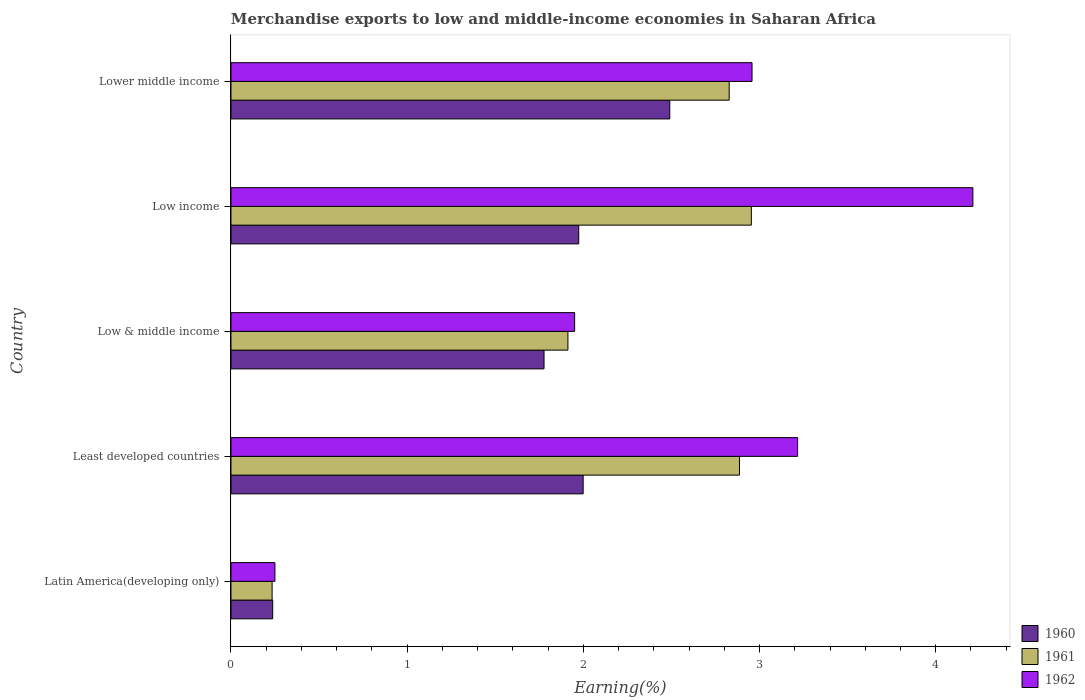Are the number of bars per tick equal to the number of legend labels?
Provide a short and direct response. Yes. Are the number of bars on each tick of the Y-axis equal?
Make the answer very short. Yes. How many bars are there on the 4th tick from the top?
Your response must be concise. 3. What is the label of the 4th group of bars from the top?
Give a very brief answer. Least developed countries. What is the percentage of amount earned from merchandise exports in 1960 in Low income?
Give a very brief answer. 1.97. Across all countries, what is the maximum percentage of amount earned from merchandise exports in 1960?
Provide a short and direct response. 2.49. Across all countries, what is the minimum percentage of amount earned from merchandise exports in 1962?
Offer a terse response. 0.25. In which country was the percentage of amount earned from merchandise exports in 1962 maximum?
Your answer should be very brief. Low income. In which country was the percentage of amount earned from merchandise exports in 1960 minimum?
Keep it short and to the point. Latin America(developing only). What is the total percentage of amount earned from merchandise exports in 1962 in the graph?
Provide a succinct answer. 12.58. What is the difference between the percentage of amount earned from merchandise exports in 1962 in Low & middle income and that in Low income?
Make the answer very short. -2.26. What is the difference between the percentage of amount earned from merchandise exports in 1962 in Latin America(developing only) and the percentage of amount earned from merchandise exports in 1961 in Low & middle income?
Provide a succinct answer. -1.66. What is the average percentage of amount earned from merchandise exports in 1962 per country?
Offer a very short reply. 2.52. What is the difference between the percentage of amount earned from merchandise exports in 1960 and percentage of amount earned from merchandise exports in 1962 in Low income?
Give a very brief answer. -2.24. What is the ratio of the percentage of amount earned from merchandise exports in 1961 in Latin America(developing only) to that in Lower middle income?
Offer a terse response. 0.08. Is the difference between the percentage of amount earned from merchandise exports in 1960 in Least developed countries and Low & middle income greater than the difference between the percentage of amount earned from merchandise exports in 1962 in Least developed countries and Low & middle income?
Give a very brief answer. No. What is the difference between the highest and the second highest percentage of amount earned from merchandise exports in 1962?
Make the answer very short. 0.99. What is the difference between the highest and the lowest percentage of amount earned from merchandise exports in 1962?
Give a very brief answer. 3.96. What does the 1st bar from the top in Latin America(developing only) represents?
Offer a very short reply. 1962. Is it the case that in every country, the sum of the percentage of amount earned from merchandise exports in 1962 and percentage of amount earned from merchandise exports in 1960 is greater than the percentage of amount earned from merchandise exports in 1961?
Offer a very short reply. Yes. How many bars are there?
Provide a short and direct response. 15. Are all the bars in the graph horizontal?
Offer a very short reply. Yes. How many countries are there in the graph?
Your answer should be very brief. 5. Does the graph contain any zero values?
Give a very brief answer. No. Does the graph contain grids?
Keep it short and to the point. No. Where does the legend appear in the graph?
Keep it short and to the point. Bottom right. How many legend labels are there?
Provide a short and direct response. 3. What is the title of the graph?
Your response must be concise. Merchandise exports to low and middle-income economies in Saharan Africa. Does "1984" appear as one of the legend labels in the graph?
Your answer should be compact. No. What is the label or title of the X-axis?
Provide a succinct answer. Earning(%). What is the label or title of the Y-axis?
Your response must be concise. Country. What is the Earning(%) of 1960 in Latin America(developing only)?
Provide a short and direct response. 0.24. What is the Earning(%) of 1961 in Latin America(developing only)?
Provide a succinct answer. 0.23. What is the Earning(%) in 1962 in Latin America(developing only)?
Keep it short and to the point. 0.25. What is the Earning(%) of 1960 in Least developed countries?
Your answer should be very brief. 2. What is the Earning(%) of 1961 in Least developed countries?
Provide a succinct answer. 2.89. What is the Earning(%) of 1962 in Least developed countries?
Give a very brief answer. 3.22. What is the Earning(%) in 1960 in Low & middle income?
Provide a succinct answer. 1.78. What is the Earning(%) of 1961 in Low & middle income?
Offer a very short reply. 1.91. What is the Earning(%) in 1962 in Low & middle income?
Keep it short and to the point. 1.95. What is the Earning(%) in 1960 in Low income?
Make the answer very short. 1.97. What is the Earning(%) in 1961 in Low income?
Make the answer very short. 2.95. What is the Earning(%) of 1962 in Low income?
Ensure brevity in your answer.  4.21. What is the Earning(%) in 1960 in Lower middle income?
Your answer should be compact. 2.49. What is the Earning(%) of 1961 in Lower middle income?
Your answer should be compact. 2.83. What is the Earning(%) of 1962 in Lower middle income?
Ensure brevity in your answer.  2.96. Across all countries, what is the maximum Earning(%) in 1960?
Keep it short and to the point. 2.49. Across all countries, what is the maximum Earning(%) of 1961?
Your answer should be very brief. 2.95. Across all countries, what is the maximum Earning(%) in 1962?
Ensure brevity in your answer.  4.21. Across all countries, what is the minimum Earning(%) in 1960?
Offer a terse response. 0.24. Across all countries, what is the minimum Earning(%) in 1961?
Provide a succinct answer. 0.23. Across all countries, what is the minimum Earning(%) of 1962?
Your response must be concise. 0.25. What is the total Earning(%) in 1960 in the graph?
Your answer should be compact. 8.48. What is the total Earning(%) of 1961 in the graph?
Keep it short and to the point. 10.81. What is the total Earning(%) in 1962 in the graph?
Your answer should be compact. 12.58. What is the difference between the Earning(%) in 1960 in Latin America(developing only) and that in Least developed countries?
Keep it short and to the point. -1.76. What is the difference between the Earning(%) of 1961 in Latin America(developing only) and that in Least developed countries?
Offer a very short reply. -2.65. What is the difference between the Earning(%) in 1962 in Latin America(developing only) and that in Least developed countries?
Your answer should be very brief. -2.97. What is the difference between the Earning(%) in 1960 in Latin America(developing only) and that in Low & middle income?
Give a very brief answer. -1.54. What is the difference between the Earning(%) in 1961 in Latin America(developing only) and that in Low & middle income?
Your answer should be very brief. -1.68. What is the difference between the Earning(%) of 1962 in Latin America(developing only) and that in Low & middle income?
Provide a succinct answer. -1.7. What is the difference between the Earning(%) of 1960 in Latin America(developing only) and that in Low income?
Keep it short and to the point. -1.74. What is the difference between the Earning(%) of 1961 in Latin America(developing only) and that in Low income?
Your answer should be compact. -2.72. What is the difference between the Earning(%) of 1962 in Latin America(developing only) and that in Low income?
Provide a short and direct response. -3.96. What is the difference between the Earning(%) in 1960 in Latin America(developing only) and that in Lower middle income?
Ensure brevity in your answer.  -2.25. What is the difference between the Earning(%) in 1961 in Latin America(developing only) and that in Lower middle income?
Provide a succinct answer. -2.59. What is the difference between the Earning(%) of 1962 in Latin America(developing only) and that in Lower middle income?
Make the answer very short. -2.71. What is the difference between the Earning(%) in 1960 in Least developed countries and that in Low & middle income?
Your response must be concise. 0.22. What is the difference between the Earning(%) in 1961 in Least developed countries and that in Low & middle income?
Your response must be concise. 0.97. What is the difference between the Earning(%) of 1962 in Least developed countries and that in Low & middle income?
Ensure brevity in your answer.  1.27. What is the difference between the Earning(%) in 1960 in Least developed countries and that in Low income?
Offer a very short reply. 0.03. What is the difference between the Earning(%) of 1961 in Least developed countries and that in Low income?
Offer a very short reply. -0.07. What is the difference between the Earning(%) in 1962 in Least developed countries and that in Low income?
Ensure brevity in your answer.  -0.99. What is the difference between the Earning(%) in 1960 in Least developed countries and that in Lower middle income?
Your response must be concise. -0.49. What is the difference between the Earning(%) in 1961 in Least developed countries and that in Lower middle income?
Offer a terse response. 0.06. What is the difference between the Earning(%) of 1962 in Least developed countries and that in Lower middle income?
Offer a very short reply. 0.26. What is the difference between the Earning(%) of 1960 in Low & middle income and that in Low income?
Offer a very short reply. -0.2. What is the difference between the Earning(%) of 1961 in Low & middle income and that in Low income?
Offer a very short reply. -1.04. What is the difference between the Earning(%) in 1962 in Low & middle income and that in Low income?
Offer a terse response. -2.26. What is the difference between the Earning(%) in 1960 in Low & middle income and that in Lower middle income?
Ensure brevity in your answer.  -0.71. What is the difference between the Earning(%) of 1961 in Low & middle income and that in Lower middle income?
Ensure brevity in your answer.  -0.92. What is the difference between the Earning(%) of 1962 in Low & middle income and that in Lower middle income?
Keep it short and to the point. -1.01. What is the difference between the Earning(%) of 1960 in Low income and that in Lower middle income?
Your answer should be compact. -0.52. What is the difference between the Earning(%) of 1961 in Low income and that in Lower middle income?
Ensure brevity in your answer.  0.13. What is the difference between the Earning(%) in 1962 in Low income and that in Lower middle income?
Give a very brief answer. 1.25. What is the difference between the Earning(%) in 1960 in Latin America(developing only) and the Earning(%) in 1961 in Least developed countries?
Your response must be concise. -2.65. What is the difference between the Earning(%) of 1960 in Latin America(developing only) and the Earning(%) of 1962 in Least developed countries?
Your answer should be compact. -2.98. What is the difference between the Earning(%) in 1961 in Latin America(developing only) and the Earning(%) in 1962 in Least developed countries?
Give a very brief answer. -2.98. What is the difference between the Earning(%) in 1960 in Latin America(developing only) and the Earning(%) in 1961 in Low & middle income?
Provide a short and direct response. -1.68. What is the difference between the Earning(%) of 1960 in Latin America(developing only) and the Earning(%) of 1962 in Low & middle income?
Keep it short and to the point. -1.71. What is the difference between the Earning(%) of 1961 in Latin America(developing only) and the Earning(%) of 1962 in Low & middle income?
Keep it short and to the point. -1.72. What is the difference between the Earning(%) of 1960 in Latin America(developing only) and the Earning(%) of 1961 in Low income?
Your response must be concise. -2.72. What is the difference between the Earning(%) in 1960 in Latin America(developing only) and the Earning(%) in 1962 in Low income?
Your response must be concise. -3.97. What is the difference between the Earning(%) in 1961 in Latin America(developing only) and the Earning(%) in 1962 in Low income?
Make the answer very short. -3.98. What is the difference between the Earning(%) in 1960 in Latin America(developing only) and the Earning(%) in 1961 in Lower middle income?
Your response must be concise. -2.59. What is the difference between the Earning(%) in 1960 in Latin America(developing only) and the Earning(%) in 1962 in Lower middle income?
Provide a short and direct response. -2.72. What is the difference between the Earning(%) in 1961 in Latin America(developing only) and the Earning(%) in 1962 in Lower middle income?
Make the answer very short. -2.72. What is the difference between the Earning(%) of 1960 in Least developed countries and the Earning(%) of 1961 in Low & middle income?
Give a very brief answer. 0.09. What is the difference between the Earning(%) in 1960 in Least developed countries and the Earning(%) in 1962 in Low & middle income?
Keep it short and to the point. 0.05. What is the difference between the Earning(%) in 1961 in Least developed countries and the Earning(%) in 1962 in Low & middle income?
Ensure brevity in your answer.  0.94. What is the difference between the Earning(%) in 1960 in Least developed countries and the Earning(%) in 1961 in Low income?
Your response must be concise. -0.95. What is the difference between the Earning(%) in 1960 in Least developed countries and the Earning(%) in 1962 in Low income?
Your answer should be compact. -2.21. What is the difference between the Earning(%) in 1961 in Least developed countries and the Earning(%) in 1962 in Low income?
Offer a very short reply. -1.32. What is the difference between the Earning(%) in 1960 in Least developed countries and the Earning(%) in 1961 in Lower middle income?
Ensure brevity in your answer.  -0.83. What is the difference between the Earning(%) of 1960 in Least developed countries and the Earning(%) of 1962 in Lower middle income?
Your response must be concise. -0.96. What is the difference between the Earning(%) of 1961 in Least developed countries and the Earning(%) of 1962 in Lower middle income?
Your answer should be compact. -0.07. What is the difference between the Earning(%) in 1960 in Low & middle income and the Earning(%) in 1961 in Low income?
Make the answer very short. -1.18. What is the difference between the Earning(%) of 1960 in Low & middle income and the Earning(%) of 1962 in Low income?
Ensure brevity in your answer.  -2.43. What is the difference between the Earning(%) in 1961 in Low & middle income and the Earning(%) in 1962 in Low income?
Keep it short and to the point. -2.3. What is the difference between the Earning(%) of 1960 in Low & middle income and the Earning(%) of 1961 in Lower middle income?
Your response must be concise. -1.05. What is the difference between the Earning(%) in 1960 in Low & middle income and the Earning(%) in 1962 in Lower middle income?
Ensure brevity in your answer.  -1.18. What is the difference between the Earning(%) of 1961 in Low & middle income and the Earning(%) of 1962 in Lower middle income?
Make the answer very short. -1.05. What is the difference between the Earning(%) of 1960 in Low income and the Earning(%) of 1961 in Lower middle income?
Give a very brief answer. -0.85. What is the difference between the Earning(%) of 1960 in Low income and the Earning(%) of 1962 in Lower middle income?
Provide a succinct answer. -0.98. What is the difference between the Earning(%) of 1961 in Low income and the Earning(%) of 1962 in Lower middle income?
Make the answer very short. -0. What is the average Earning(%) in 1960 per country?
Your answer should be very brief. 1.7. What is the average Earning(%) in 1961 per country?
Provide a short and direct response. 2.16. What is the average Earning(%) of 1962 per country?
Keep it short and to the point. 2.52. What is the difference between the Earning(%) in 1960 and Earning(%) in 1961 in Latin America(developing only)?
Your answer should be compact. 0. What is the difference between the Earning(%) in 1960 and Earning(%) in 1962 in Latin America(developing only)?
Provide a succinct answer. -0.01. What is the difference between the Earning(%) of 1961 and Earning(%) of 1962 in Latin America(developing only)?
Your response must be concise. -0.02. What is the difference between the Earning(%) in 1960 and Earning(%) in 1961 in Least developed countries?
Provide a short and direct response. -0.89. What is the difference between the Earning(%) of 1960 and Earning(%) of 1962 in Least developed countries?
Make the answer very short. -1.22. What is the difference between the Earning(%) in 1961 and Earning(%) in 1962 in Least developed countries?
Give a very brief answer. -0.33. What is the difference between the Earning(%) of 1960 and Earning(%) of 1961 in Low & middle income?
Provide a short and direct response. -0.14. What is the difference between the Earning(%) of 1960 and Earning(%) of 1962 in Low & middle income?
Give a very brief answer. -0.17. What is the difference between the Earning(%) in 1961 and Earning(%) in 1962 in Low & middle income?
Your answer should be compact. -0.04. What is the difference between the Earning(%) in 1960 and Earning(%) in 1961 in Low income?
Ensure brevity in your answer.  -0.98. What is the difference between the Earning(%) of 1960 and Earning(%) of 1962 in Low income?
Offer a very short reply. -2.24. What is the difference between the Earning(%) in 1961 and Earning(%) in 1962 in Low income?
Make the answer very short. -1.26. What is the difference between the Earning(%) in 1960 and Earning(%) in 1961 in Lower middle income?
Make the answer very short. -0.34. What is the difference between the Earning(%) in 1960 and Earning(%) in 1962 in Lower middle income?
Provide a short and direct response. -0.47. What is the difference between the Earning(%) in 1961 and Earning(%) in 1962 in Lower middle income?
Offer a terse response. -0.13. What is the ratio of the Earning(%) of 1960 in Latin America(developing only) to that in Least developed countries?
Offer a very short reply. 0.12. What is the ratio of the Earning(%) in 1961 in Latin America(developing only) to that in Least developed countries?
Make the answer very short. 0.08. What is the ratio of the Earning(%) of 1962 in Latin America(developing only) to that in Least developed countries?
Keep it short and to the point. 0.08. What is the ratio of the Earning(%) in 1960 in Latin America(developing only) to that in Low & middle income?
Give a very brief answer. 0.13. What is the ratio of the Earning(%) of 1961 in Latin America(developing only) to that in Low & middle income?
Offer a terse response. 0.12. What is the ratio of the Earning(%) in 1962 in Latin America(developing only) to that in Low & middle income?
Your answer should be very brief. 0.13. What is the ratio of the Earning(%) of 1960 in Latin America(developing only) to that in Low income?
Ensure brevity in your answer.  0.12. What is the ratio of the Earning(%) of 1961 in Latin America(developing only) to that in Low income?
Give a very brief answer. 0.08. What is the ratio of the Earning(%) in 1962 in Latin America(developing only) to that in Low income?
Your answer should be compact. 0.06. What is the ratio of the Earning(%) in 1960 in Latin America(developing only) to that in Lower middle income?
Your response must be concise. 0.1. What is the ratio of the Earning(%) of 1961 in Latin America(developing only) to that in Lower middle income?
Give a very brief answer. 0.08. What is the ratio of the Earning(%) of 1962 in Latin America(developing only) to that in Lower middle income?
Your answer should be very brief. 0.08. What is the ratio of the Earning(%) in 1960 in Least developed countries to that in Low & middle income?
Ensure brevity in your answer.  1.12. What is the ratio of the Earning(%) of 1961 in Least developed countries to that in Low & middle income?
Provide a short and direct response. 1.51. What is the ratio of the Earning(%) in 1962 in Least developed countries to that in Low & middle income?
Ensure brevity in your answer.  1.65. What is the ratio of the Earning(%) of 1960 in Least developed countries to that in Low income?
Your answer should be compact. 1.01. What is the ratio of the Earning(%) of 1961 in Least developed countries to that in Low income?
Make the answer very short. 0.98. What is the ratio of the Earning(%) of 1962 in Least developed countries to that in Low income?
Ensure brevity in your answer.  0.76. What is the ratio of the Earning(%) of 1960 in Least developed countries to that in Lower middle income?
Make the answer very short. 0.8. What is the ratio of the Earning(%) of 1961 in Least developed countries to that in Lower middle income?
Ensure brevity in your answer.  1.02. What is the ratio of the Earning(%) in 1962 in Least developed countries to that in Lower middle income?
Make the answer very short. 1.09. What is the ratio of the Earning(%) of 1960 in Low & middle income to that in Low income?
Make the answer very short. 0.9. What is the ratio of the Earning(%) in 1961 in Low & middle income to that in Low income?
Keep it short and to the point. 0.65. What is the ratio of the Earning(%) in 1962 in Low & middle income to that in Low income?
Keep it short and to the point. 0.46. What is the ratio of the Earning(%) in 1960 in Low & middle income to that in Lower middle income?
Your answer should be very brief. 0.71. What is the ratio of the Earning(%) in 1961 in Low & middle income to that in Lower middle income?
Your answer should be very brief. 0.68. What is the ratio of the Earning(%) in 1962 in Low & middle income to that in Lower middle income?
Your answer should be compact. 0.66. What is the ratio of the Earning(%) of 1960 in Low income to that in Lower middle income?
Provide a succinct answer. 0.79. What is the ratio of the Earning(%) in 1961 in Low income to that in Lower middle income?
Give a very brief answer. 1.04. What is the ratio of the Earning(%) in 1962 in Low income to that in Lower middle income?
Your answer should be compact. 1.42. What is the difference between the highest and the second highest Earning(%) of 1960?
Keep it short and to the point. 0.49. What is the difference between the highest and the second highest Earning(%) of 1961?
Provide a short and direct response. 0.07. What is the difference between the highest and the lowest Earning(%) of 1960?
Keep it short and to the point. 2.25. What is the difference between the highest and the lowest Earning(%) in 1961?
Offer a terse response. 2.72. What is the difference between the highest and the lowest Earning(%) of 1962?
Provide a succinct answer. 3.96. 